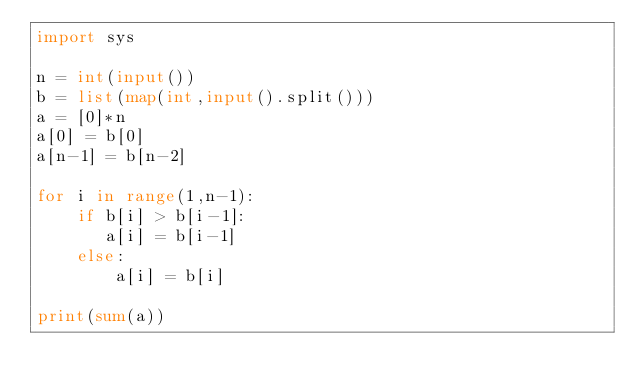Convert code to text. <code><loc_0><loc_0><loc_500><loc_500><_Python_>import sys

n = int(input())
b = list(map(int,input().split()))
a = [0]*n
a[0] = b[0]
a[n-1] = b[n-2]

for i in range(1,n-1):
    if b[i] > b[i-1]:
       a[i] = b[i-1]
    else:
        a[i] = b[i]

print(sum(a))
</code> 